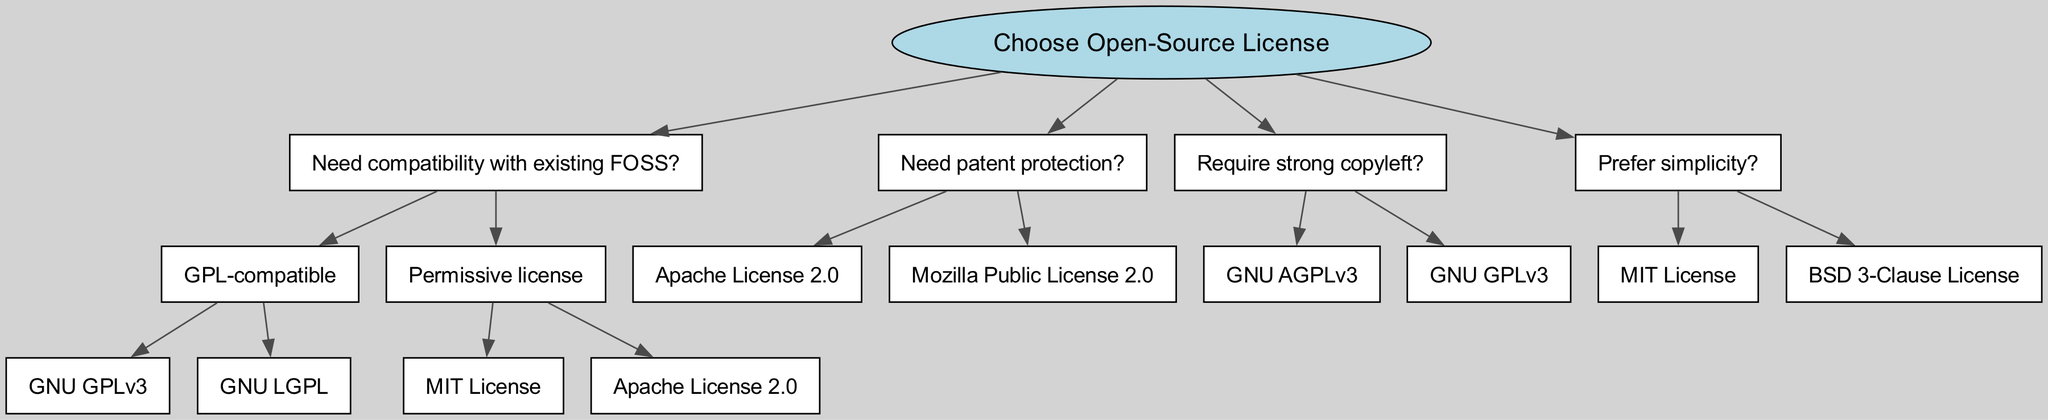What is the root node of the diagram? The root node is the starting point of the decision tree, labeled as "Choose Open-Source License." This node branches out to various factors that influence the choice of license based on user needs.
Answer: Choose Open-Source License How many licenses are listed under "GPL-compatible"? The "GPL-compatible" branch has two child nodes, specifically "GNU GPLv3" and "GNU LGPL," indicating that there are two licenses under this category.
Answer: 2 Which license offers patent protection? The "Need patent protection?" node leads to two licenses: "Apache License 2.0" and "Mozilla Public License 2.0." Thus, these licenses are specifically associated with patent protection.
Answer: Apache License 2.0, Mozilla Public License 2.0 What is the preference depicted under "Require strong copyleft"? The node "Require strong copyleft?" leads to two options: "GNU AGPLv3" and "GNU GPLv3." This indicates a clear preference for licenses that ensure strong copyleft provisions under this criterion.
Answer: GNU AGPLv3, GNU GPLv3 What will be the outcome if the user prefers simplicity? Following the "Prefer simplicity?" path, the diagram indicates two suitable licenses that prioritize simplicity: "MIT License" and "BSD 3-Clause License." Hence, the outcome for this preference is the selection of either of these two licenses.
Answer: MIT License, BSD 3-Clause License If someone chooses a "permissive license," what licenses are available? The "Need compatibility with existing FOSS?" node branches to "Permissive license," which includes two options: "MIT License" and "Apache License 2.0." As a result, these licenses provide flexibility without strong copyleft restrictions.
Answer: MIT License, Apache License 2.0 What are the next steps if one requires both compatibility and patent protection? To achieve compatibility, the node "Need compatibility with existing FOSS?" must be followed. If this also requires patent protection, one must traverse to the "Need patent protection?" node as the two can overlap. The final options available would include "Apache License 2.0" since it falls under both categories.
Answer: Apache License 2.0 How many total nodes are in the diagram? The diagram contains a total of 11 nodes, including the root and all branching licenses and decisions based on user requirements, indicating the complexity of choices available.
Answer: 11 What distinguishes the "GNU AGPLv3" from "GNU GPLv3"? Both licenses appear under the "Require strong copyleft?" category; however, the distinction lies in their specific provisions, where "GNU AGPLv3" demands source disclosure for network use, while "GNU GPLv3" does not. The choice reflects the nature of distribution and use of software.
Answer: AGPL has network use provisions 